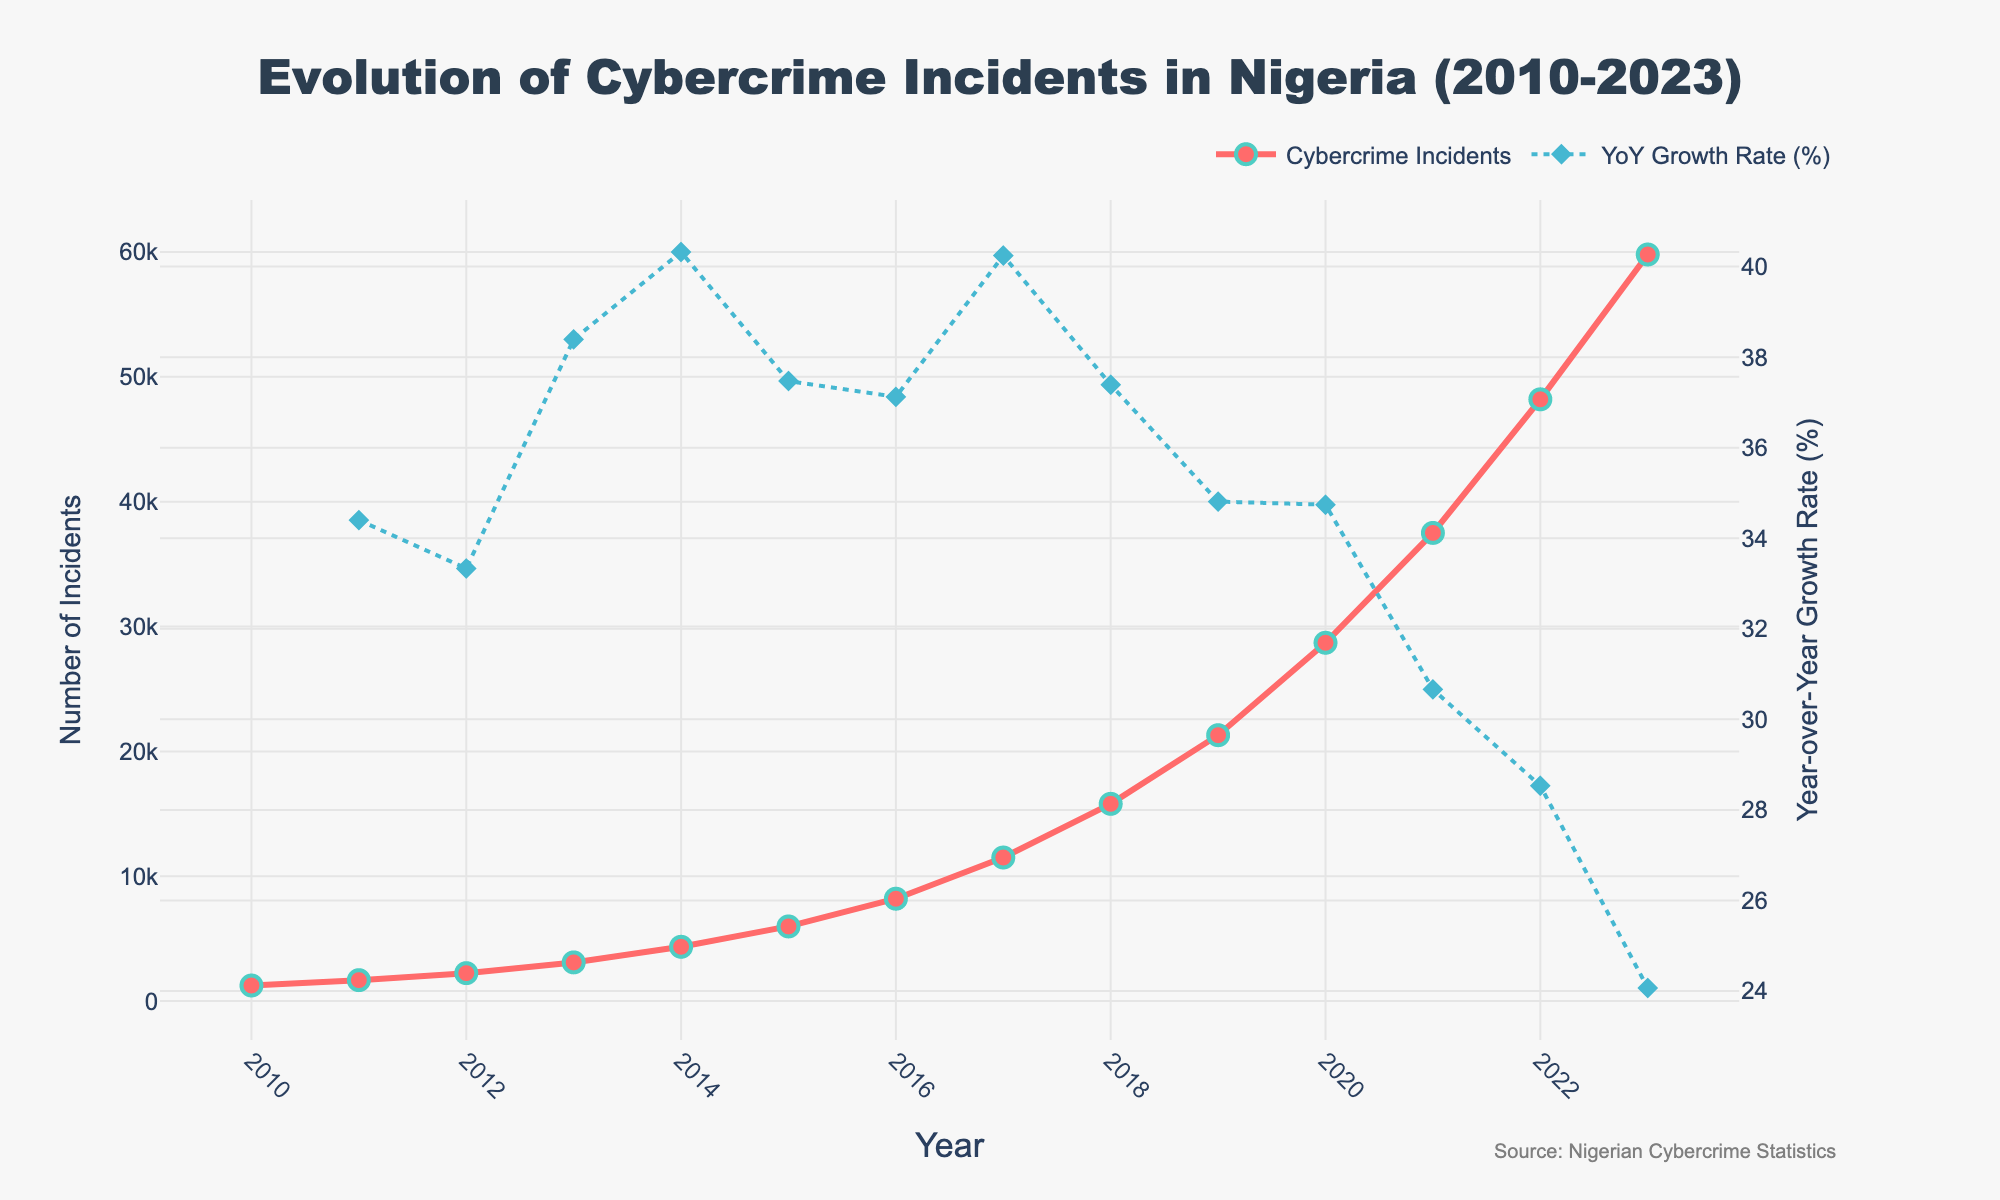How many cybercrime incidents were reported in 2015 and 2020? Looking at the chart, the cybercrime incidents reported are 5980 for 2015 and 28700 for 2020.
Answer: 5980 for 2015, 28700 for 2020 By how much did the number of cybercrime incidents increase from 2010 to 2023? Subtract the incidents in 2010 from the incidents in 2023: 59800 - 1250 = 58550.
Answer: 58550 What is the trend of cybercrime incidents between 2010 to 2023? The number of cybercrime incidents consistently increases every year from 2010 to 2023, showing an upward trend.
Answer: Upward trend Which year had the highest Year-over-Year growth rate in cybercrime incidents? Referring to the Year-over-Year growth rate line, identify the peak point which is in the year 2014.
Answer: 2014 What was the Year-over-Year growth rate percentage for the year 2018? Look at the YoY growth rate line for the year 2018, which appears to be around 37%.
Answer: ~37% Compare the cybercrime incidents of 2012 to 2014. By what percentage did they increase? Calculate the percentage increase: ((4350 - 2240) / 2240) * 100 = 94.2%.
Answer: 94.2% Which color represents the number of cybercrime incidents and which color represents the YoY growth rate on the chart? The number of cybercrime incidents is represented by red, and the YoY growth rate is represented by blue.
Answer: Red for incidents, Blue for YoY growth In which years did the number of cybercrime incidents exceed 20,000? Referring to the cybercrime incidents line, the incidents exceed 20,000 in the years 2019, 2020, 2021, 2022, and 2023.
Answer: 2019, 2020, 2021, 2022, 2023 